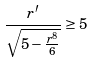<formula> <loc_0><loc_0><loc_500><loc_500>\frac { r ^ { \prime } } { \sqrt { 5 - \frac { r ^ { 8 } } { 6 } } } \geq 5</formula> 